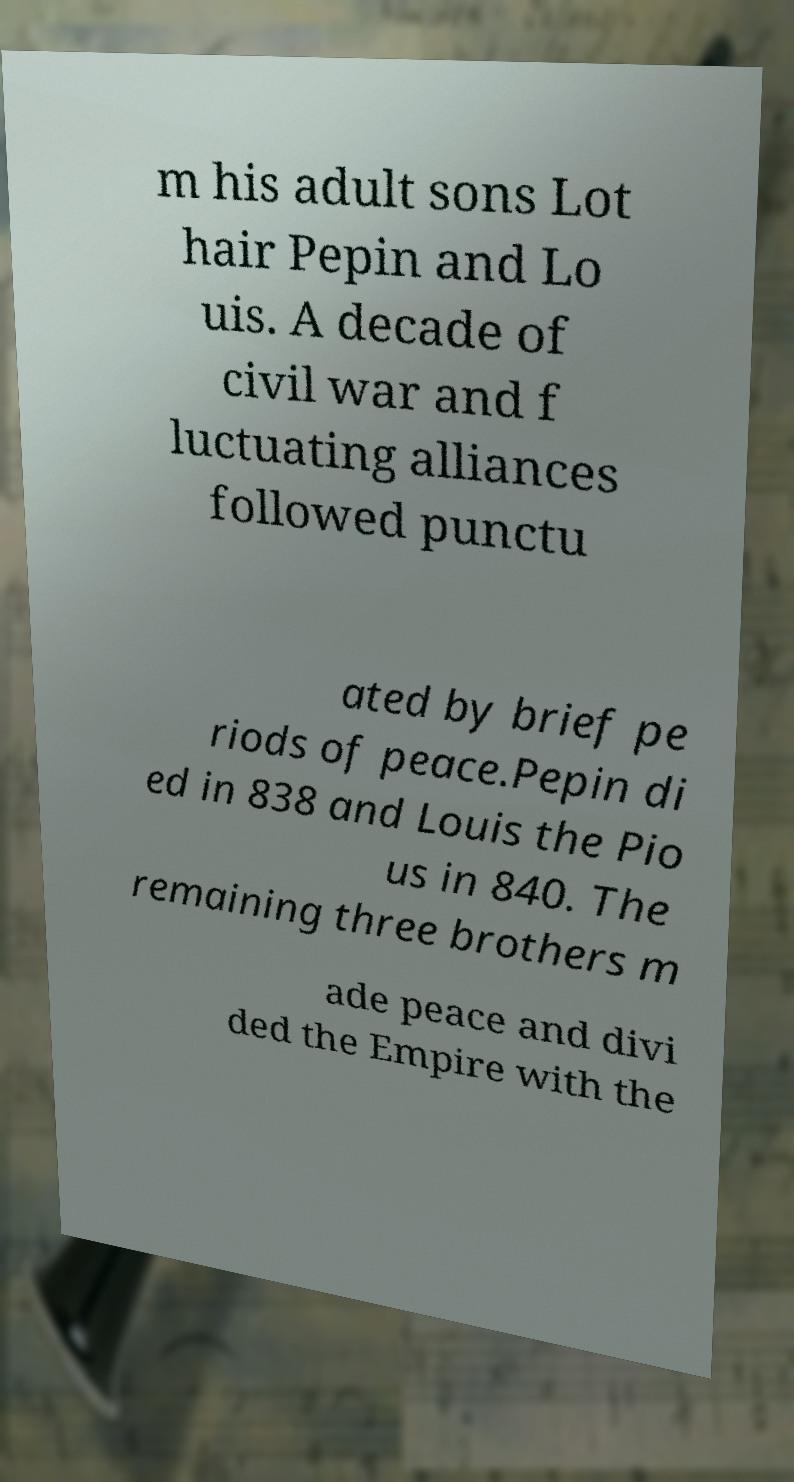Can you accurately transcribe the text from the provided image for me? m his adult sons Lot hair Pepin and Lo uis. A decade of civil war and f luctuating alliances followed punctu ated by brief pe riods of peace.Pepin di ed in 838 and Louis the Pio us in 840. The remaining three brothers m ade peace and divi ded the Empire with the 